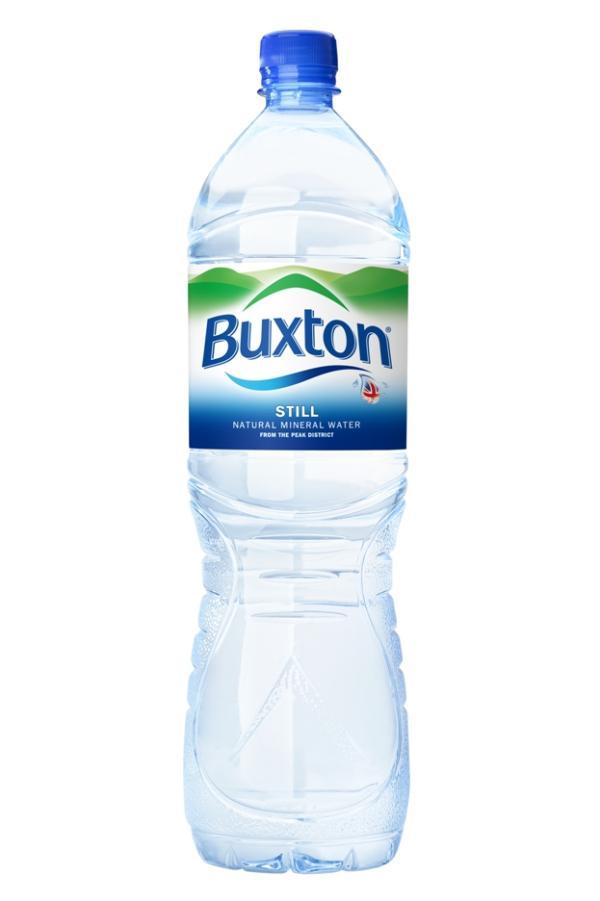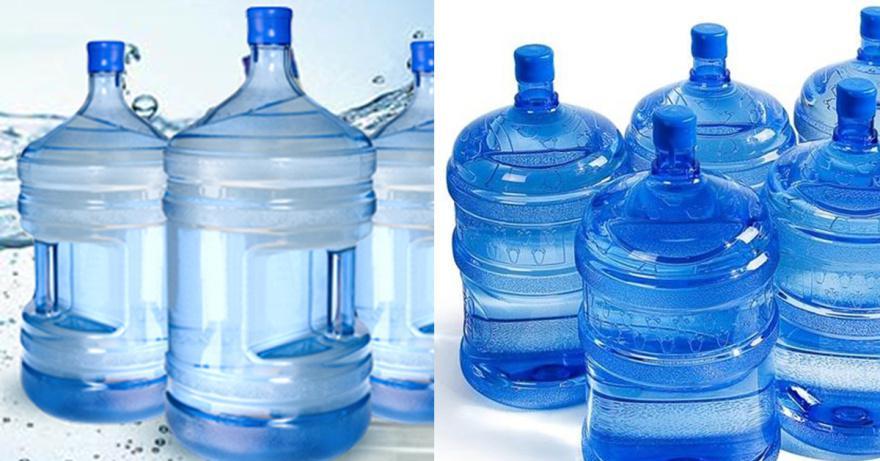The first image is the image on the left, the second image is the image on the right. Examine the images to the left and right. Is the description "There is exactly one water bottle in the image on the left." accurate? Answer yes or no. Yes. The first image is the image on the left, the second image is the image on the right. For the images displayed, is the sentence "An image shows exactly one water bottle." factually correct? Answer yes or no. Yes. 